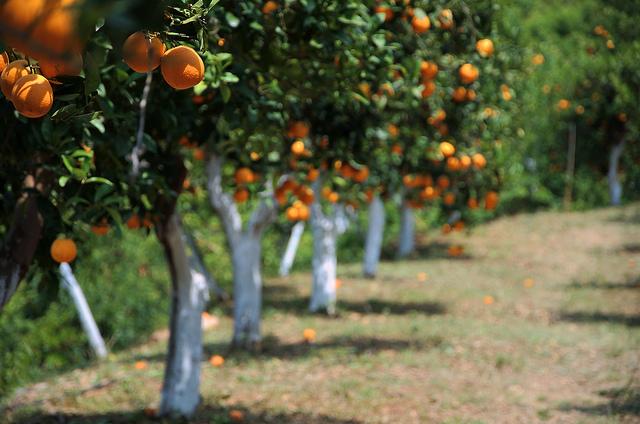Is the fruit ripe?
Short answer required. Yes. Are the fruits falling?
Be succinct. Yes. Is the sun coming from the right or the left of the picture?
Short answer required. Right. Could this scene be in Alaska?
Be succinct. No. 